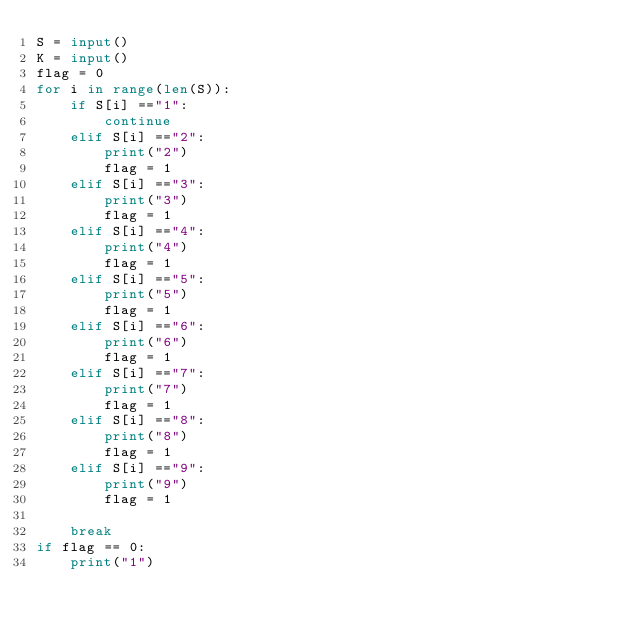Convert code to text. <code><loc_0><loc_0><loc_500><loc_500><_Python_>S = input()
K = input()
flag = 0
for i in range(len(S)):
    if S[i] =="1":
        continue
    elif S[i] =="2":
        print("2")
        flag = 1
    elif S[i] =="3":
        print("3")
        flag = 1
    elif S[i] =="4":
        print("4")
        flag = 1
    elif S[i] =="5":
        print("5")
        flag = 1
    elif S[i] =="6":
        print("6")
        flag = 1
    elif S[i] =="7":
        print("7")
        flag = 1
    elif S[i] =="8":
        print("8")
        flag = 1
    elif S[i] =="9":
        print("9")
        flag = 1

    break
if flag == 0:
    print("1")
</code> 